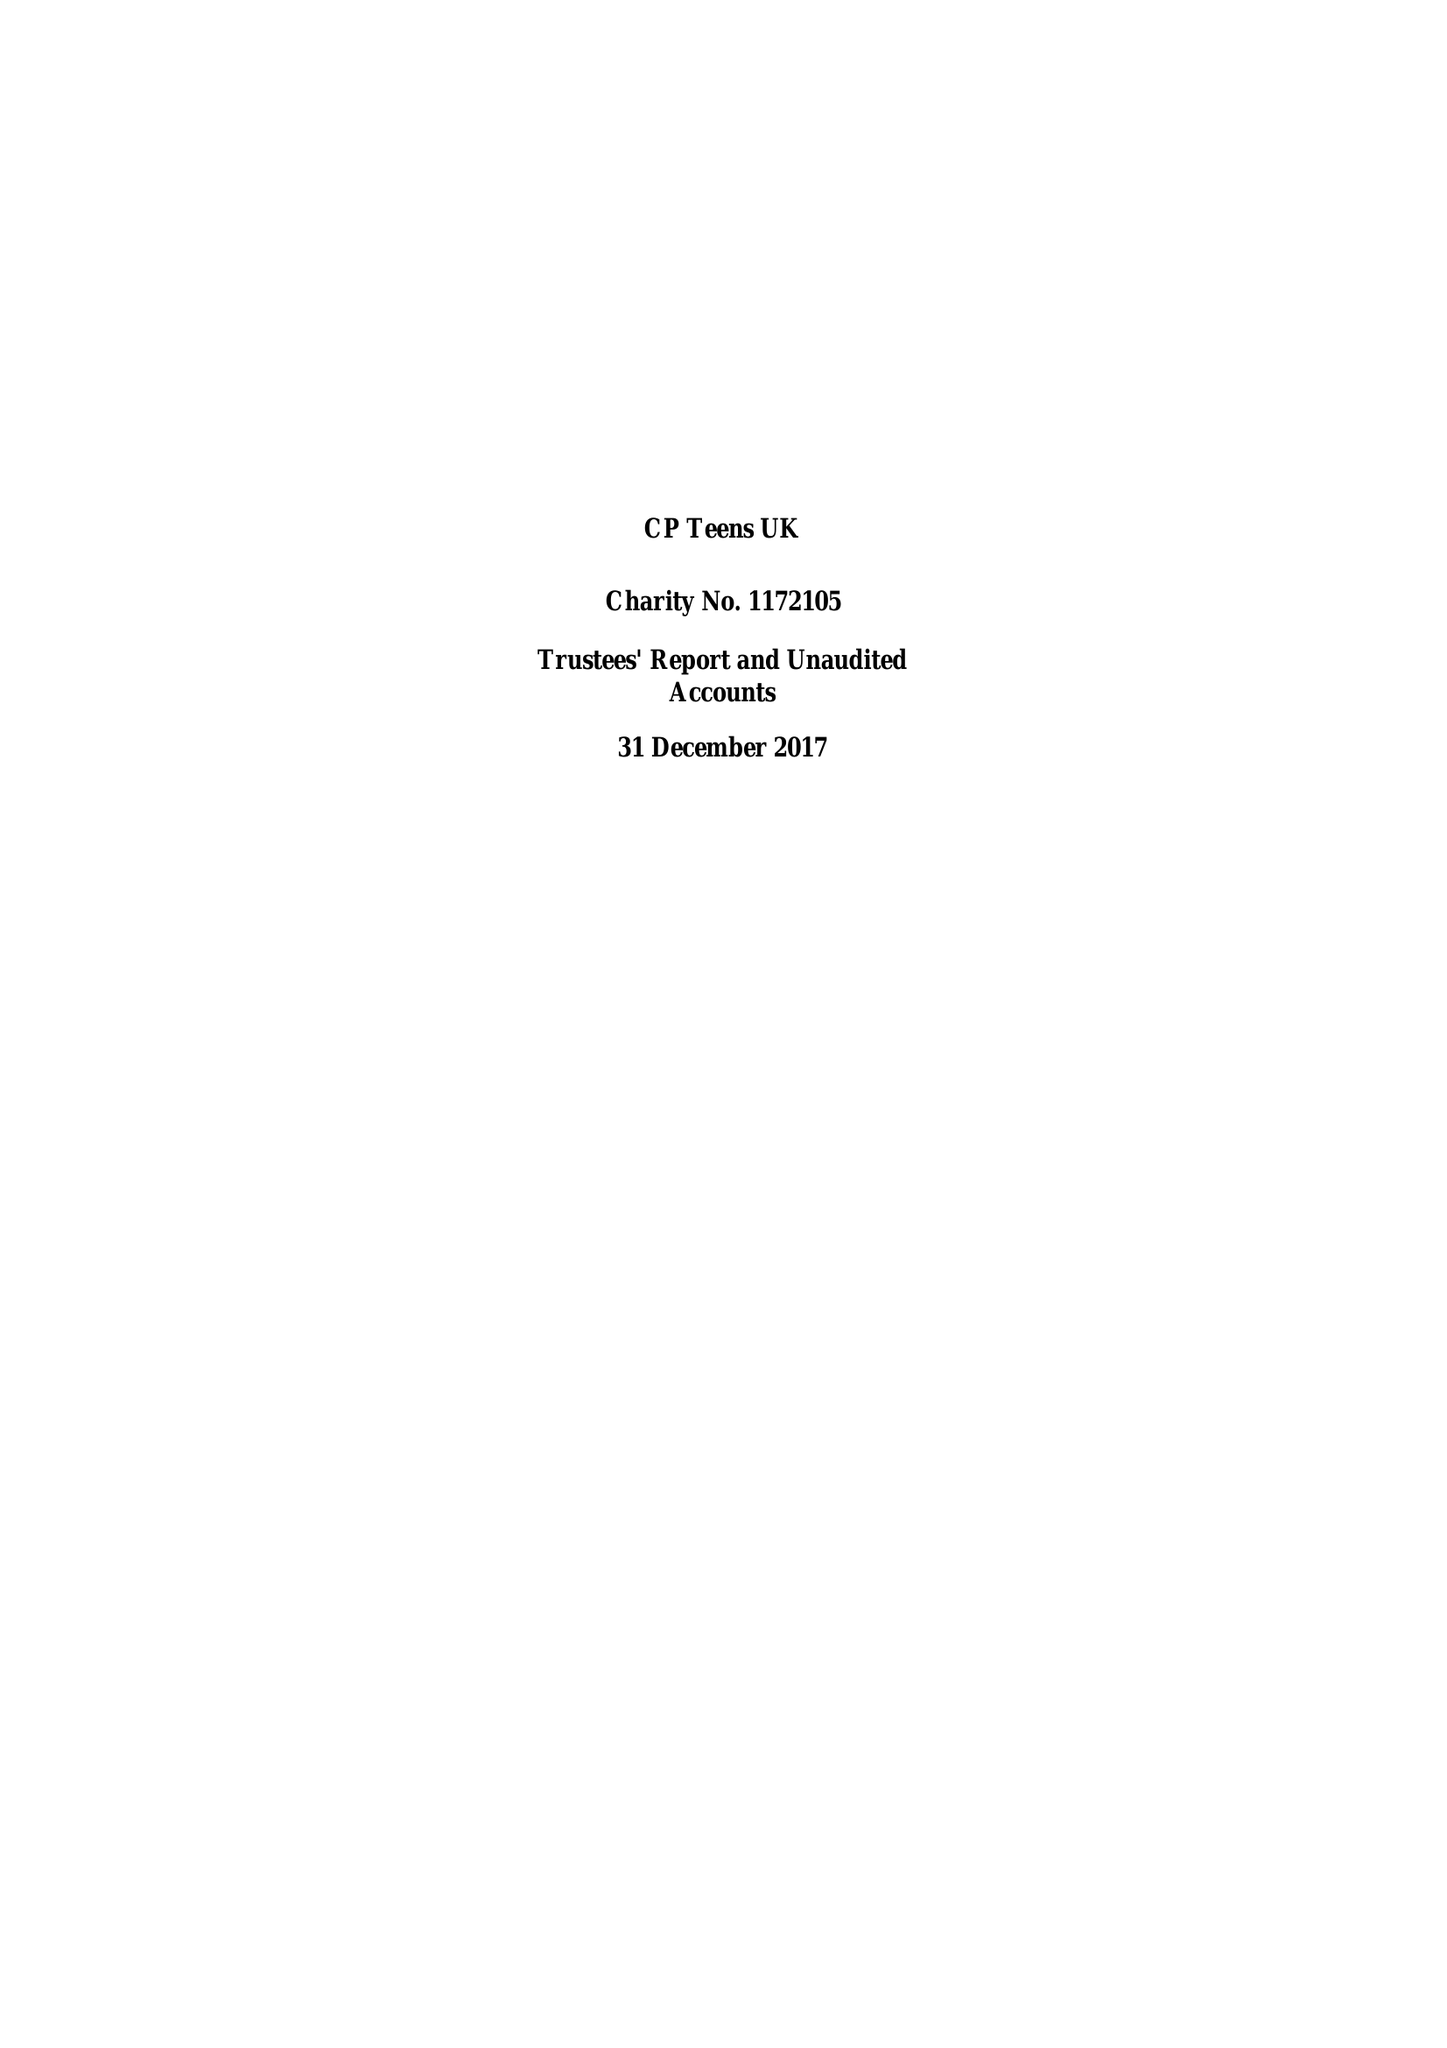What is the value for the address__street_line?
Answer the question using a single word or phrase. 21 SANDSTONE AVENUE 